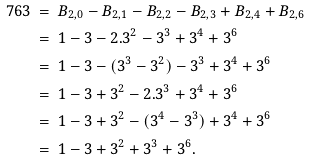Convert formula to latex. <formula><loc_0><loc_0><loc_500><loc_500>7 6 3 & \ = \ B _ { 2 , 0 } - B _ { 2 , 1 } - B _ { 2 , 2 } - B _ { 2 , 3 } + B _ { 2 , 4 } + B _ { 2 , 6 } \\ & \ = \ 1 - 3 - 2 . 3 ^ { 2 } - 3 ^ { 3 } + 3 ^ { 4 } + 3 ^ { 6 } \\ & \ = \ 1 - 3 - ( 3 ^ { 3 } - 3 ^ { 2 } ) - 3 ^ { 3 } + 3 ^ { 4 } + 3 ^ { 6 } \\ & \ = \ 1 - 3 + 3 ^ { 2 } - 2 . 3 ^ { 3 } + 3 ^ { 4 } + 3 ^ { 6 } \\ & \ = \ 1 - 3 + 3 ^ { 2 } - ( 3 ^ { 4 } - 3 ^ { 3 } ) + 3 ^ { 4 } + 3 ^ { 6 } \\ & \ = \ 1 - 3 + 3 ^ { 2 } + 3 ^ { 3 } + 3 ^ { 6 } .</formula> 